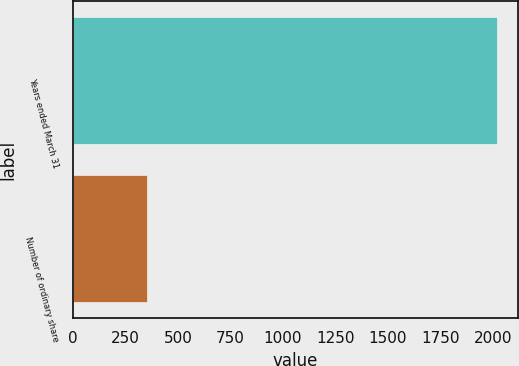Convert chart. <chart><loc_0><loc_0><loc_500><loc_500><bar_chart><fcel>Years ended March 31<fcel>Number of ordinary share<nl><fcel>2019<fcel>352<nl></chart> 